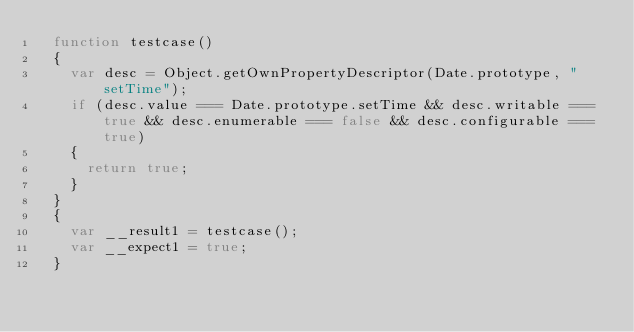<code> <loc_0><loc_0><loc_500><loc_500><_JavaScript_>  function testcase() 
  {
    var desc = Object.getOwnPropertyDescriptor(Date.prototype, "setTime");
    if (desc.value === Date.prototype.setTime && desc.writable === true && desc.enumerable === false && desc.configurable === true)
    {
      return true;
    }
  }
  {
    var __result1 = testcase();
    var __expect1 = true;
  }
  </code> 